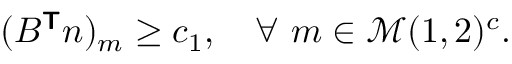Convert formula to latex. <formula><loc_0><loc_0><loc_500><loc_500>\begin{array} { r } { ( B ^ { T } n ) _ { m } \geq c _ { 1 } , \quad \forall \ m \in \mathcal { M } ( 1 , 2 ) ^ { c } . } \end{array}</formula> 